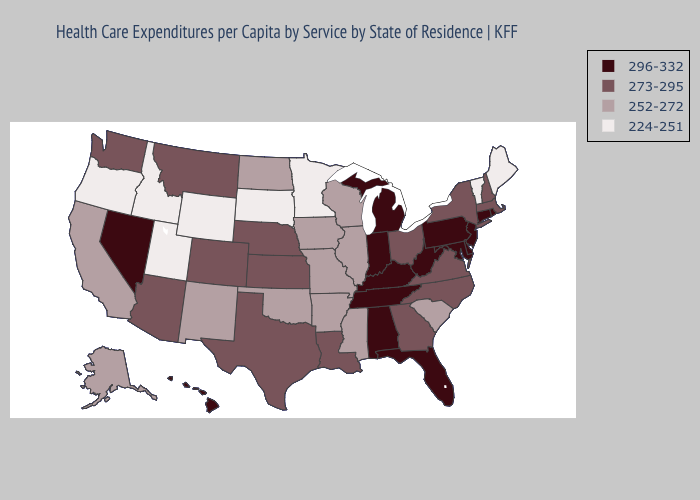Name the states that have a value in the range 273-295?
Write a very short answer. Arizona, Colorado, Georgia, Kansas, Louisiana, Massachusetts, Montana, Nebraska, New Hampshire, New York, North Carolina, Ohio, Texas, Virginia, Washington. Does Arizona have a lower value than Indiana?
Write a very short answer. Yes. Among the states that border West Virginia , does Virginia have the highest value?
Give a very brief answer. No. How many symbols are there in the legend?
Concise answer only. 4. What is the value of Arizona?
Answer briefly. 273-295. Which states have the lowest value in the Northeast?
Write a very short answer. Maine, Vermont. Among the states that border Connecticut , does Massachusetts have the highest value?
Be succinct. No. Which states hav the highest value in the Northeast?
Concise answer only. Connecticut, New Jersey, Pennsylvania, Rhode Island. What is the value of Delaware?
Quick response, please. 296-332. Name the states that have a value in the range 224-251?
Short answer required. Idaho, Maine, Minnesota, Oregon, South Dakota, Utah, Vermont, Wyoming. Does North Dakota have the lowest value in the USA?
Be succinct. No. What is the highest value in states that border Louisiana?
Keep it brief. 273-295. Does New Hampshire have the highest value in the Northeast?
Write a very short answer. No. Does Hawaii have the highest value in the USA?
Write a very short answer. Yes. Which states hav the highest value in the South?
Keep it brief. Alabama, Delaware, Florida, Kentucky, Maryland, Tennessee, West Virginia. 